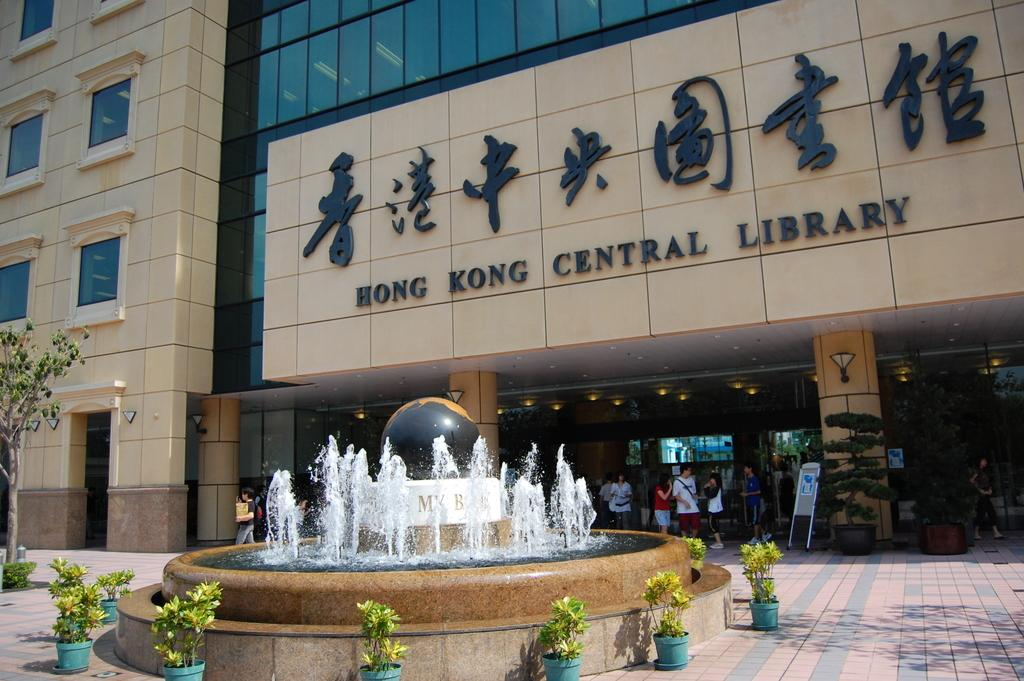Provide a one-sentence caption for the provided image. The Hong Kong Central Library has a fountain in front of the entrance. 